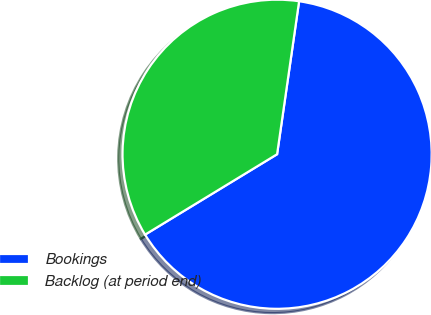Convert chart to OTSL. <chart><loc_0><loc_0><loc_500><loc_500><pie_chart><fcel>Bookings<fcel>Backlog (at period end)<nl><fcel>64.02%<fcel>35.98%<nl></chart> 